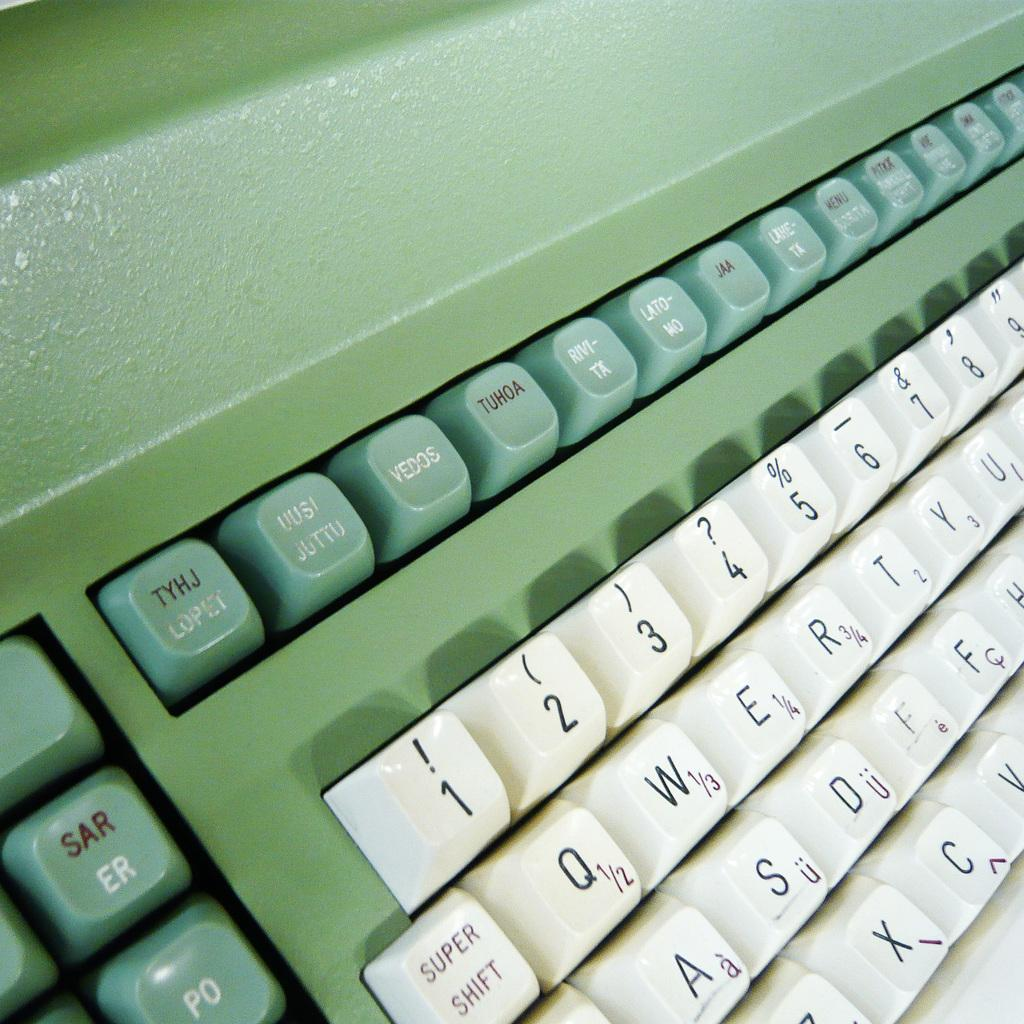Provide a one-sentence caption for the provided image. a keyboard with the letters qwert on it. 